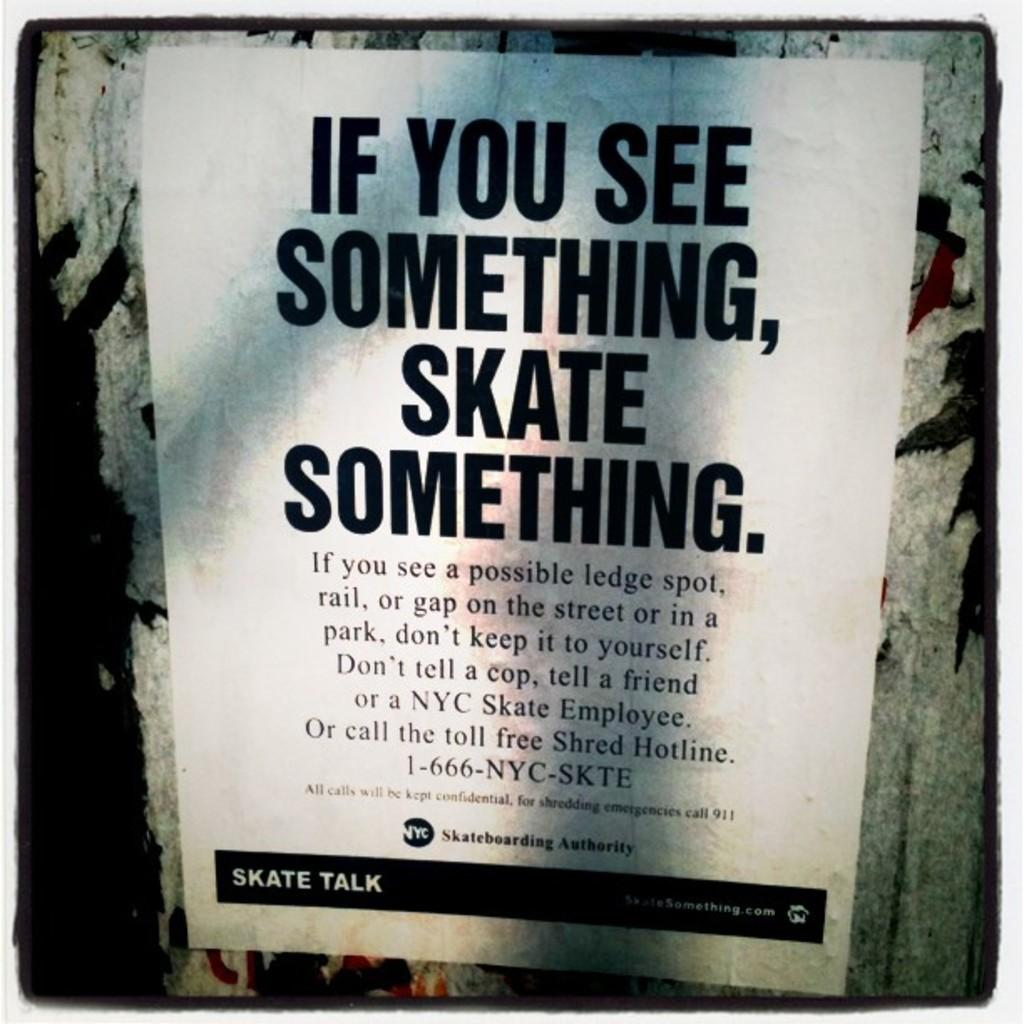<image>
Relay a brief, clear account of the picture shown. A flyer encourages skating on things you see including ledges and gaps on the street. 